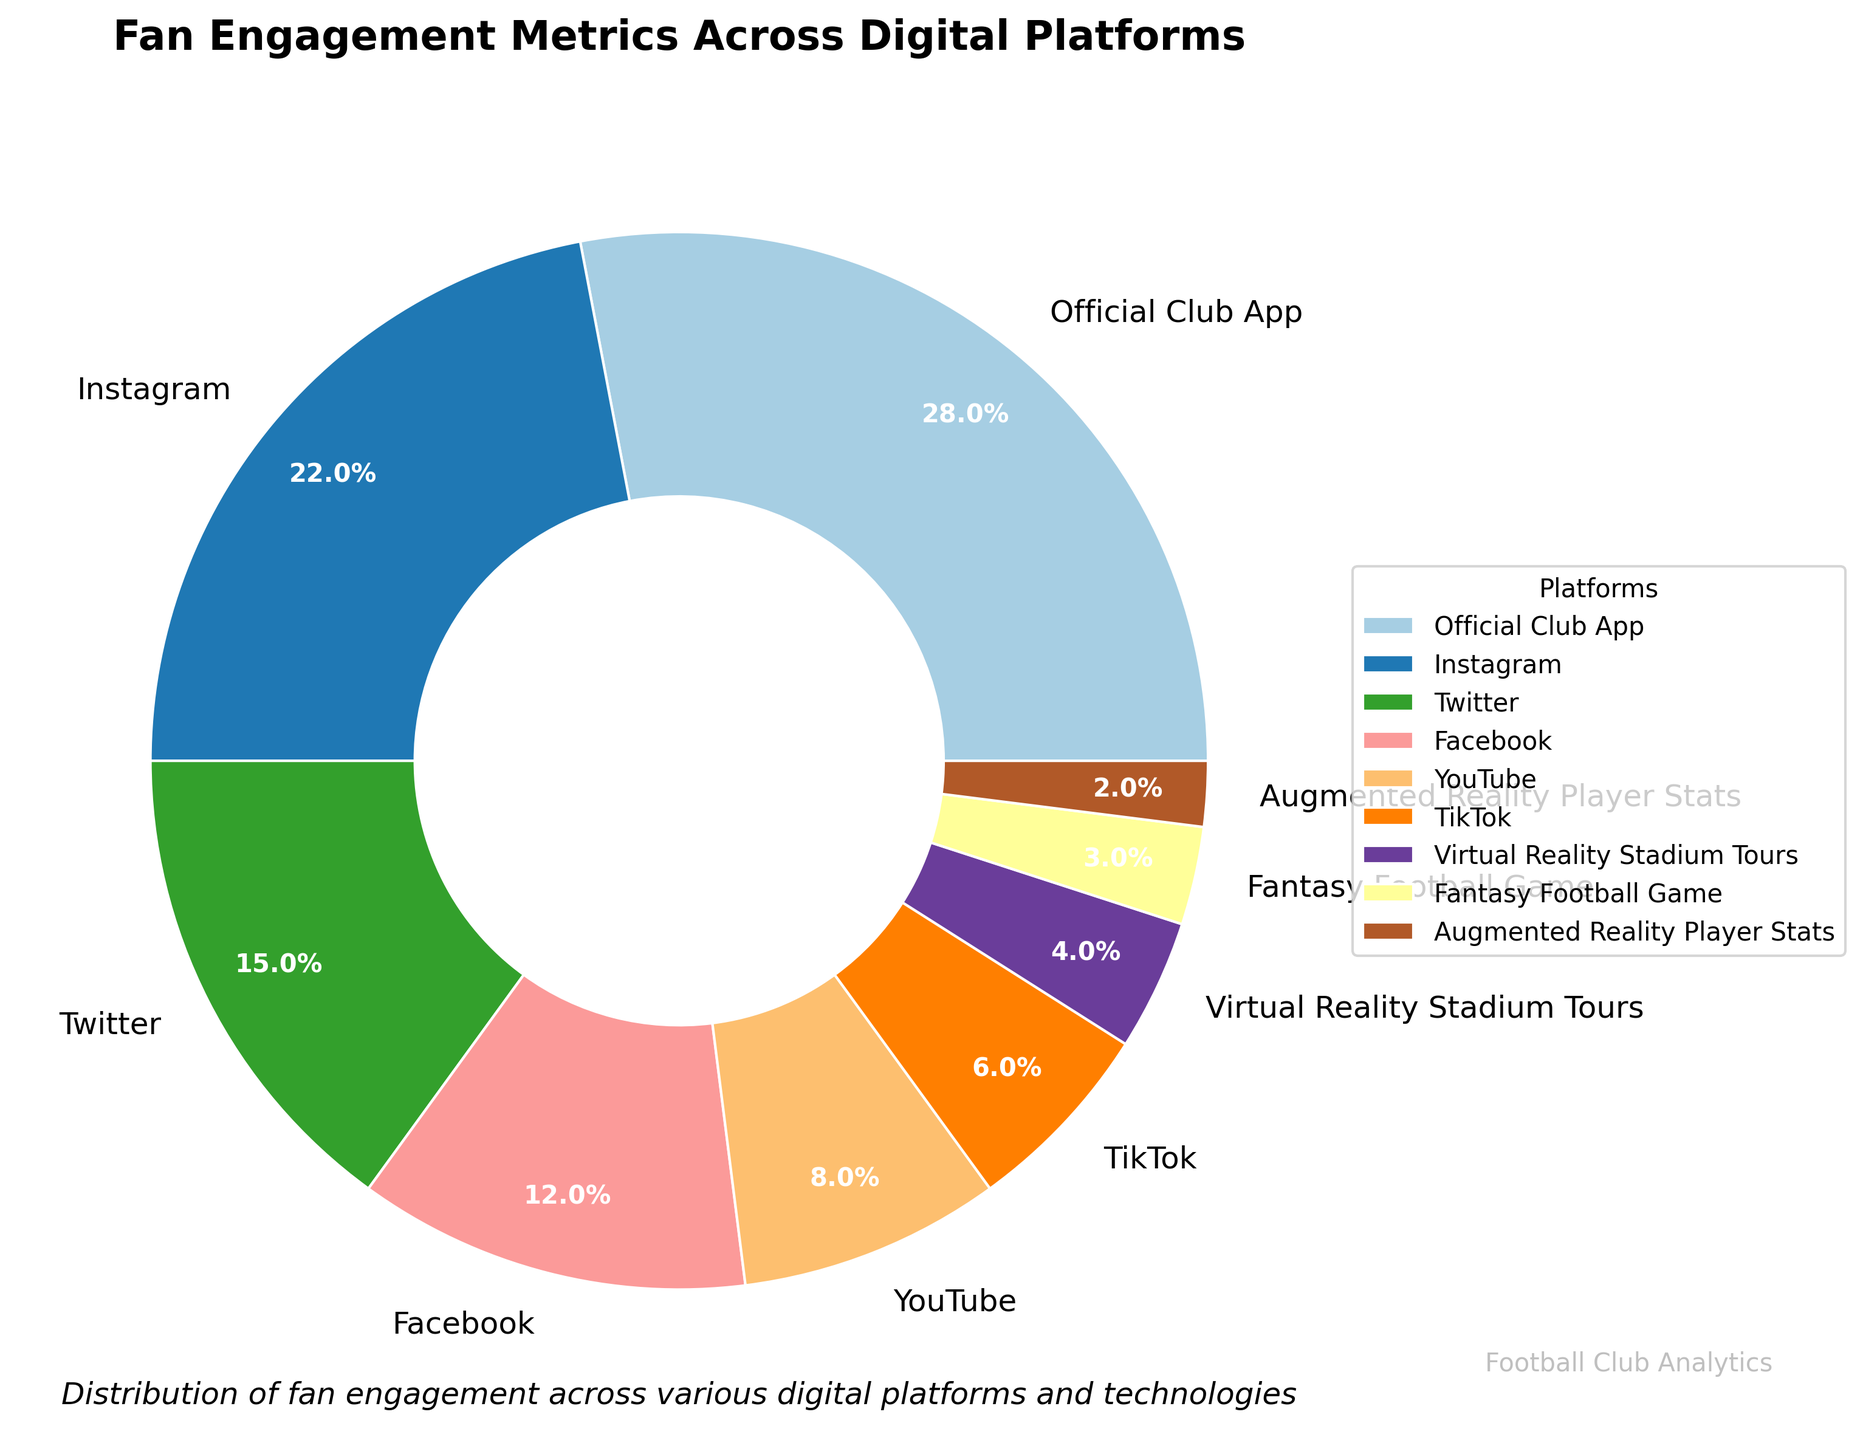What's the percentage of fans engaging on Instagram? The pie chart shows percentages for each platform, and Instagram has a label with 22%.
Answer: 22% Which platform has the highest fan engagement? The pie chart shows segments for different platforms, and the largest segment is for the Official Club App with a label indicating 28%.
Answer: Official Club App What is the combined percentage of fan engagement for Official Club App and Instagram? The percentages are given directly: Official Club App is 28% and Instagram is 22%. Adding them gives 28% + 22% = 50%.
Answer: 50% How does the engagement on Twitter compare to Facebook? The pie chart shows Twitter with 15% and Facebook with 12%. Therefore, Twitter has a higher engagement than Facebook.
Answer: Twitter has higher engagement than Facebook What percentage of fan engagement comes from emerging technologies like Virtual Reality Stadium Tours and Augmented Reality Player Stats? Virtual Reality Stadium Tours is 4% and Augmented Reality Player Stats is 2%. Adding them gives 4% + 2% = 6%.
Answer: 6% Rank the platforms from highest to lowest engagement. The pie chart shows the following percentages: Official Club App (28%), Instagram (22%), Twitter (15%), Facebook (12%), YouTube (8%), TikTok (6%), Virtual Reality Stadium Tours (4%), Fantasy Football Game (3%), Augmented Reality Player Stats (2%). Therefore, ranking them in descending order is: Official Club App > Instagram > Twitter > Facebook > YouTube > TikTok > Virtual Reality Stadium Tours > Fantasy Football Game > Augmented Reality Player Stats.
Answer: Official Club App, Instagram, Twitter, Facebook, YouTube, TikTok, Virtual Reality Stadium Tours, Fantasy Football Game, Augmented Reality Player Stats Which platform has a smaller percentage of engagement: YouTube or TikTok, and by how much? The pie chart indicates YouTube at 8% and TikTok at 6%. The difference is 8% - 6% = 2%.
Answer: TikTok by 2% What is the average percentage of engagement across all platforms? The percentages are: 28%, 22%, 15%, 12%, 8%, 6%, 4%, 3%, and 2%. Summing them up gives 100%. Dividing by 9 platforms gives 100% / 9 ≈ 11.11%.
Answer: 11.11% How much more engagement does the Official Club App have compared to Fantasy Football Game? The pie chart shows Official Club App at 28% and Fantasy Football Game at 3%. The difference is 28% - 3% = 25%.
Answer: 25% What are the visual attributes used to represent the different platforms in the pie chart? The pie chart uses different colors from a custom color palette to represent each platform. Additionally, text labels and percentages are displayed within each segment.
Answer: Different colors, text labels, percentages 